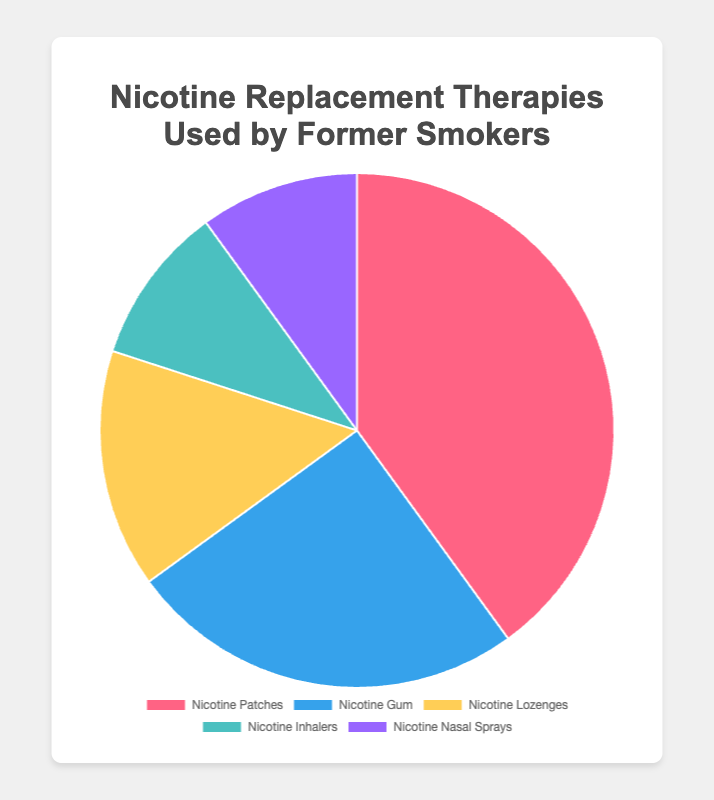What is the most commonly used Nicotine Replacement Therapy by former smokers? By looking at the pie chart, we can see which segment is the largest. In this case, "Nicotine Patches" has the largest segment, accounting for 40%.
Answer: Nicotine Patches Which two therapies are used by an equal percentage of former smokers? The pie chart shows "Nicotine Inhalers" and "Nicotine Nasal Sprays" each occupy the same size segments of the pie chart, both accounting for 10%.
Answer: Nicotine Inhalers and Nicotine Nasal Sprays How much more popular are nicotine patches than nicotine gum? From the pie chart, "Nicotine Patches" account for 40%, and "Nicotine Gum" account for 25%. To find how much more popular nicotine patches are, we subtract the percentage of gum users from the patches users: 40% - 25% = 15%.
Answer: 15% What is the total percentage of former smokers using therapies other than nicotine patches? To find this, we add up the percentages of the other categories: Nicotine Gum (25%), Nicotine Lozenges (15%), Nicotine Inhalers (10%), and Nicotine Nasal Sprays (10%). The total is 25% + 15% + 10% + 10% = 60%.
Answer: 60% Which nicotine replacement therapy is the least popular? By examining the pie chart, we see that "Nicotine Lozenges," "Nicotine Inhalers," and "Nicotine Nasal Sprays" are the smallest segments. However, each of these two therapies—Inhalers and Nasal Sprays—occupies 10%, the least amongst the options.
Answer: Nicotine Lozenges, Nicotine Inhalers, and Nicotine Nasal Sprays 